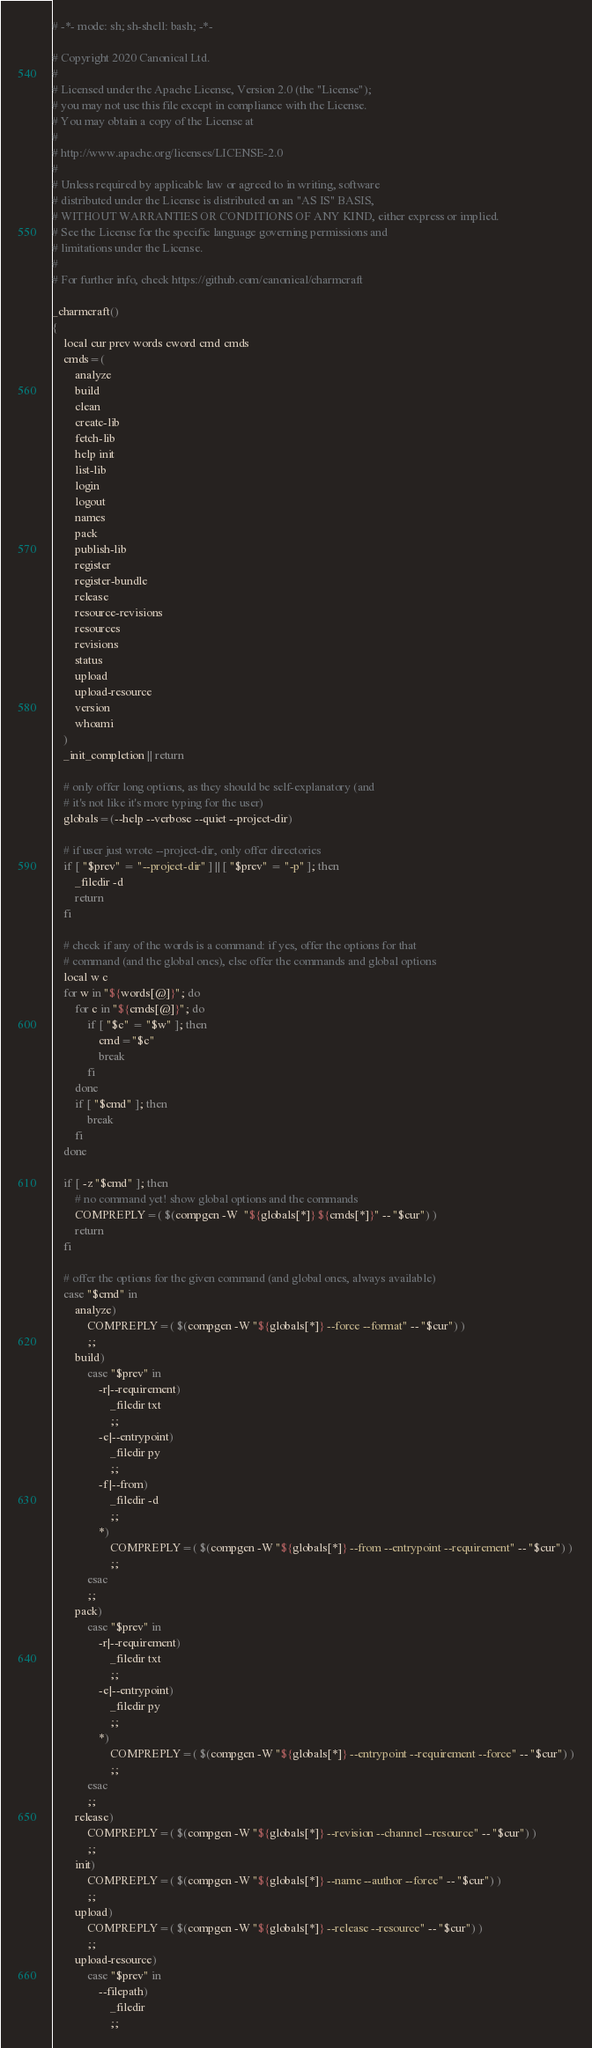Convert code to text. <code><loc_0><loc_0><loc_500><loc_500><_Bash_># -*- mode: sh; sh-shell: bash; -*-

# Copyright 2020 Canonical Ltd.
#
# Licensed under the Apache License, Version 2.0 (the "License");
# you may not use this file except in compliance with the License.
# You may obtain a copy of the License at
#
# http://www.apache.org/licenses/LICENSE-2.0
#
# Unless required by applicable law or agreed to in writing, software
# distributed under the License is distributed on an "AS IS" BASIS,
# WITHOUT WARRANTIES OR CONDITIONS OF ANY KIND, either express or implied.
# See the License for the specific language governing permissions and
# limitations under the License.
#
# For further info, check https://github.com/canonical/charmcraft

_charmcraft()
{
    local cur prev words cword cmd cmds
    cmds=(
        analyze
        build
        clean
        create-lib 
        fetch-lib 
        help init 
        list-lib 
        login 
        logout 
        names 
        pack 
        publish-lib 
        register 
        register-bundle
        release 
        resource-revisions
        resources
        revisions 
        status 
        upload 
        upload-resource
        version 
        whoami
    )
    _init_completion || return

    # only offer long options, as they should be self-explanatory (and
    # it's not like it's more typing for the user)
    globals=(--help --verbose --quiet --project-dir)

    # if user just wrote --project-dir, only offer directories
    if [ "$prev" = "--project-dir" ] || [ "$prev" = "-p" ]; then
        _filedir -d
        return
    fi

    # check if any of the words is a command: if yes, offer the options for that 
    # command (and the global ones), else offer the commands and global options
    local w c
    for w in "${words[@]}"; do
        for c in "${cmds[@]}"; do
            if [ "$c" = "$w" ]; then
                cmd="$c"
                break
            fi
        done
        if [ "$cmd" ]; then
            break
        fi
    done

    if [ -z "$cmd" ]; then
        # no command yet! show global options and the commands
        COMPREPLY=( $(compgen -W  "${globals[*]} ${cmds[*]}" -- "$cur") )
        return
    fi

    # offer the options for the given command (and global ones, always available)
    case "$cmd" in
        analyze)
            COMPREPLY=( $(compgen -W "${globals[*]} --force --format" -- "$cur") )
            ;;
        build)
            case "$prev" in
                -r|--requirement)
                    _filedir txt
                    ;;
                -e|--entrypoint)
                    _filedir py
                    ;;
                -f|--from)
                    _filedir -d
                    ;;
                *)
                    COMPREPLY=( $(compgen -W "${globals[*]} --from --entrypoint --requirement" -- "$cur") )
                    ;;
            esac
            ;;
        pack)
            case "$prev" in
                -r|--requirement)
                    _filedir txt
                    ;;
                -e|--entrypoint)
                    _filedir py
                    ;;
                *)
                    COMPREPLY=( $(compgen -W "${globals[*]} --entrypoint --requirement --force" -- "$cur") )
                    ;;
            esac
            ;;
        release)
            COMPREPLY=( $(compgen -W "${globals[*]} --revision --channel --resource" -- "$cur") )
            ;;
        init)
            COMPREPLY=( $(compgen -W "${globals[*]} --name --author --force" -- "$cur") )
            ;;
        upload)
            COMPREPLY=( $(compgen -W "${globals[*]} --release --resource" -- "$cur") )
            ;;
        upload-resource)
            case "$prev" in
                --filepath)
                    _filedir
                    ;;</code> 